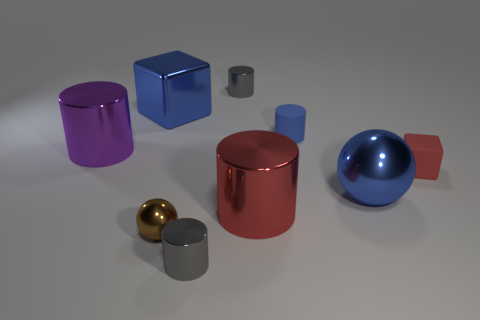The small red rubber thing is what shape?
Keep it short and to the point. Cube. How many other things are there of the same material as the small brown ball?
Provide a succinct answer. 6. What is the color of the large shiny cylinder to the right of the big purple cylinder that is in front of the tiny metal thing that is behind the red matte block?
Give a very brief answer. Red. What is the material of the red cube that is the same size as the matte cylinder?
Your answer should be compact. Rubber. How many things are tiny gray metallic cylinders behind the large metallic cube or metallic things?
Make the answer very short. 7. Is there a big metallic object?
Offer a very short reply. Yes. There is a gray cylinder in front of the large blue cube; what is its material?
Give a very brief answer. Metal. There is a tiny cylinder that is the same color as the metal block; what material is it?
Offer a terse response. Rubber. What number of big objects are purple cylinders or brown matte blocks?
Offer a very short reply. 1. What color is the tiny rubber cylinder?
Make the answer very short. Blue. 